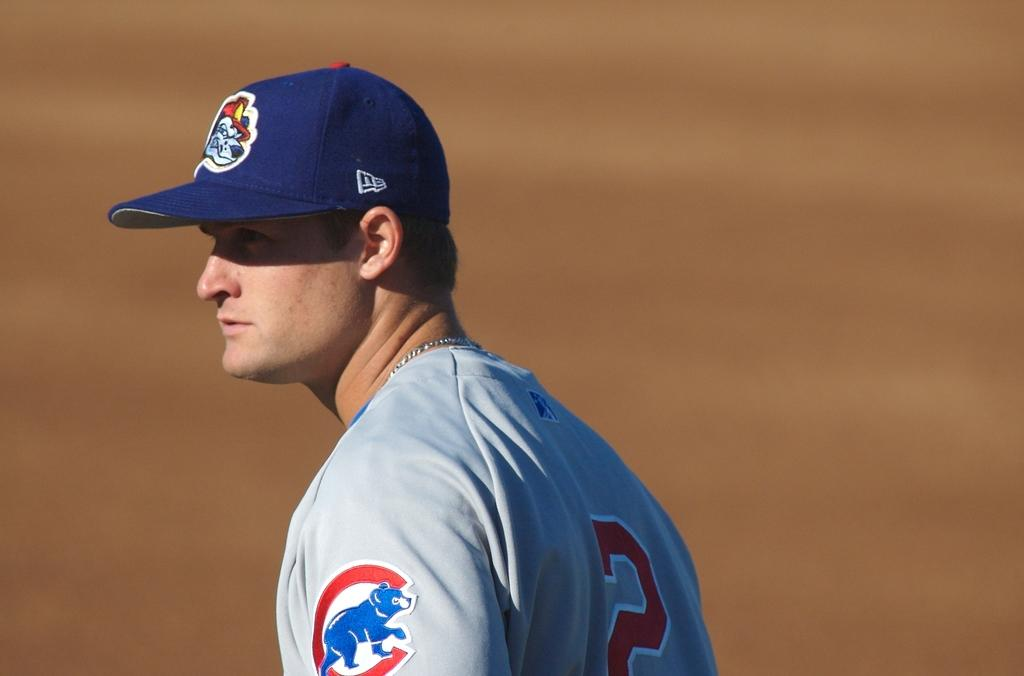What is the main subject of the image? There is a man in the image. What type of crook does the man need to fix the problem in the image? There is no crook or problem mentioned in the image; it only features a man. 